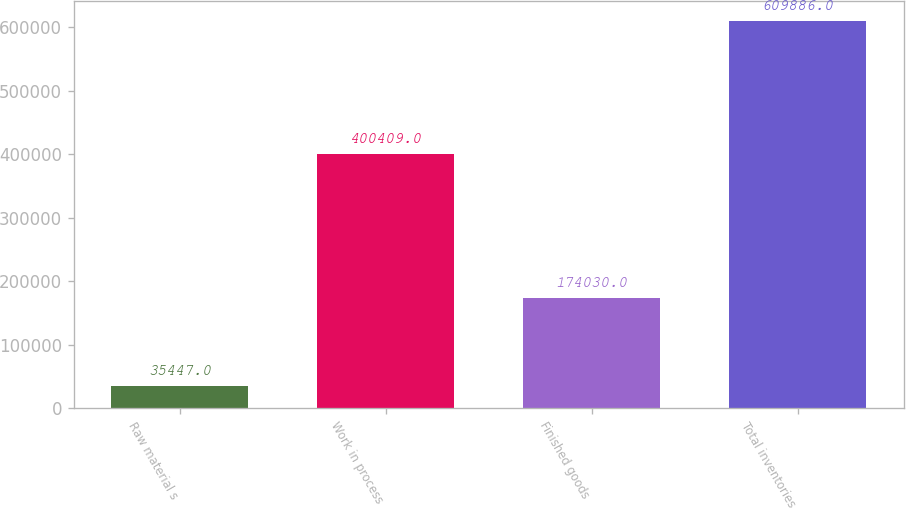Convert chart to OTSL. <chart><loc_0><loc_0><loc_500><loc_500><bar_chart><fcel>Raw material s<fcel>Work in process<fcel>Finished goods<fcel>Total inventories<nl><fcel>35447<fcel>400409<fcel>174030<fcel>609886<nl></chart> 